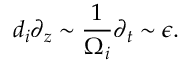Convert formula to latex. <formula><loc_0><loc_0><loc_500><loc_500>d _ { i } \partial _ { z } \sim \frac { 1 } { \Omega _ { i } } \partial _ { t } \sim \epsilon .</formula> 